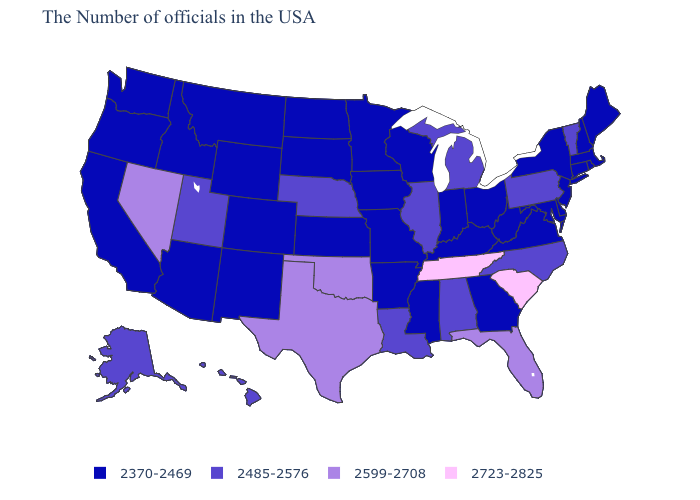What is the value of Mississippi?
Give a very brief answer. 2370-2469. What is the value of California?
Answer briefly. 2370-2469. Name the states that have a value in the range 2485-2576?
Quick response, please. Vermont, Pennsylvania, North Carolina, Michigan, Alabama, Illinois, Louisiana, Nebraska, Utah, Alaska, Hawaii. Name the states that have a value in the range 2370-2469?
Quick response, please. Maine, Massachusetts, Rhode Island, New Hampshire, Connecticut, New York, New Jersey, Delaware, Maryland, Virginia, West Virginia, Ohio, Georgia, Kentucky, Indiana, Wisconsin, Mississippi, Missouri, Arkansas, Minnesota, Iowa, Kansas, South Dakota, North Dakota, Wyoming, Colorado, New Mexico, Montana, Arizona, Idaho, California, Washington, Oregon. Does North Carolina have the lowest value in the USA?
Give a very brief answer. No. What is the value of Washington?
Quick response, please. 2370-2469. Which states have the highest value in the USA?
Be succinct. South Carolina, Tennessee. Which states have the highest value in the USA?
Write a very short answer. South Carolina, Tennessee. What is the value of Illinois?
Write a very short answer. 2485-2576. Name the states that have a value in the range 2723-2825?
Answer briefly. South Carolina, Tennessee. Name the states that have a value in the range 2485-2576?
Keep it brief. Vermont, Pennsylvania, North Carolina, Michigan, Alabama, Illinois, Louisiana, Nebraska, Utah, Alaska, Hawaii. Does Hawaii have the highest value in the West?
Write a very short answer. No. What is the highest value in states that border Colorado?
Keep it brief. 2599-2708. Does Michigan have the lowest value in the USA?
Give a very brief answer. No. Does the map have missing data?
Write a very short answer. No. 